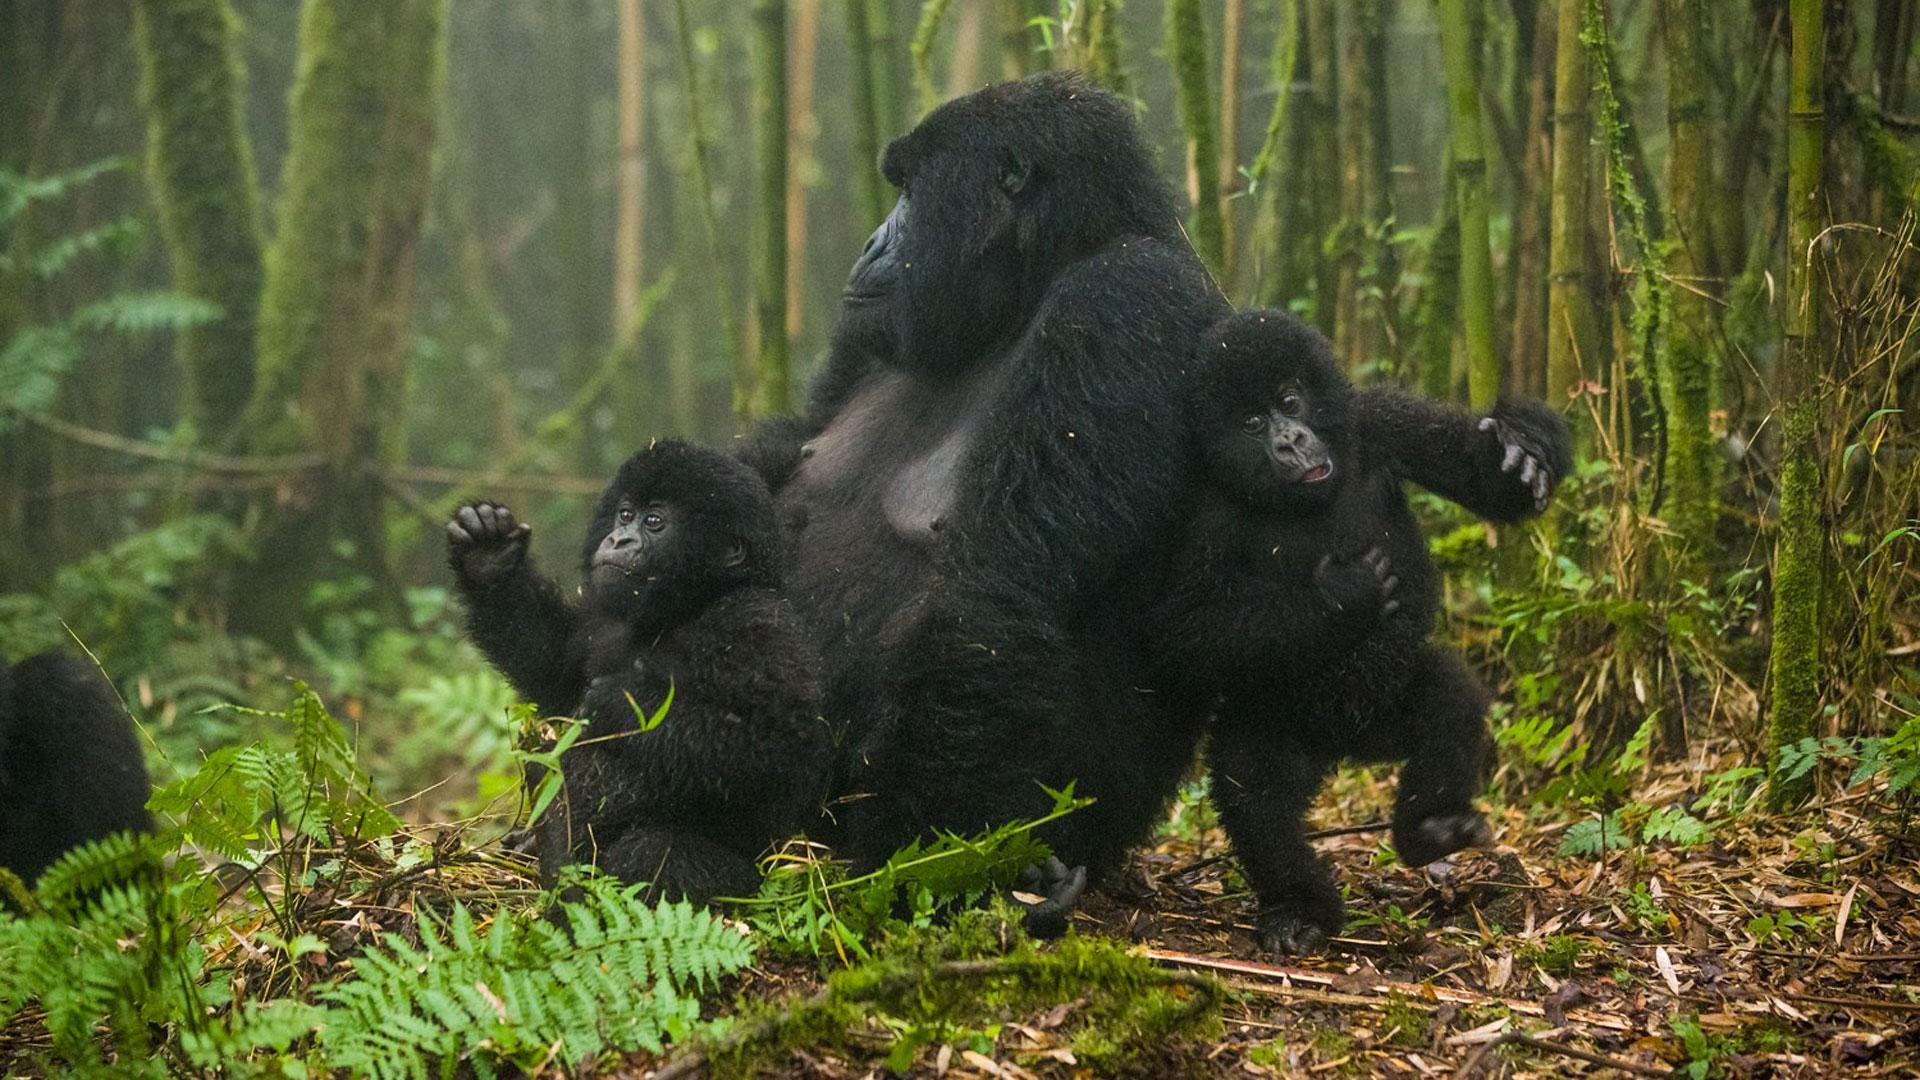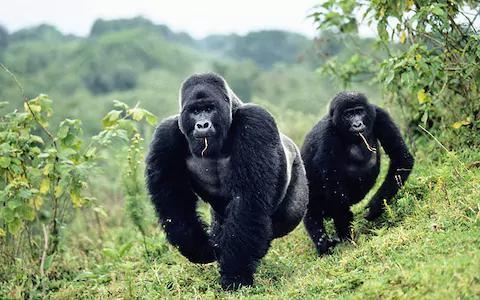The first image is the image on the left, the second image is the image on the right. Considering the images on both sides, is "There are exactly five gorillas." valid? Answer yes or no. Yes. 